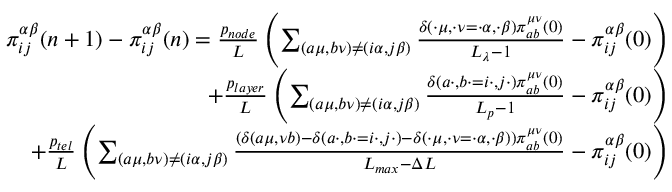<formula> <loc_0><loc_0><loc_500><loc_500>\begin{array} { r } { \pi _ { i j } ^ { \alpha \beta } ( n + 1 ) - \pi _ { i j } ^ { \alpha \beta } ( n ) = \frac { p _ { n o d e } } { L } \left ( \sum _ { ( a \mu , b \nu ) \neq ( i \alpha , j \beta ) } \frac { \delta ( \cdot \mu , \cdot \nu = \cdot \alpha , \cdot \beta ) \pi _ { a b } ^ { \mu \nu } ( 0 ) } { L _ { \lambda } - 1 } - \pi _ { i j } ^ { \alpha \beta } ( 0 ) \right ) } \\ { + \frac { p _ { l a y e r } } { L } \left ( \sum _ { ( a \mu , b \nu ) \neq ( i \alpha , j \beta ) } \frac { \delta ( a \cdot , b \cdot = i \cdot , j \cdot ) \pi _ { a b } ^ { \mu \nu } ( 0 ) } { L _ { p } - 1 } - \pi _ { i j } ^ { \alpha \beta } ( 0 ) \right ) } \\ { + \frac { p _ { t e l } } { L } \left ( \sum _ { ( a \mu , b \nu ) \neq ( i \alpha , j \beta ) } \frac { \left ( \delta ( a \mu , \nu b ) - \delta ( a \cdot , b \cdot = i \cdot , j \cdot ) - \delta ( \cdot \mu , \cdot \nu = \cdot \alpha , \cdot \beta ) \right ) \pi _ { a b } ^ { \mu \nu } ( 0 ) } { L _ { \max } - \Delta L } - \pi _ { i j } ^ { \alpha \beta } ( 0 ) \right ) } \end{array}</formula> 